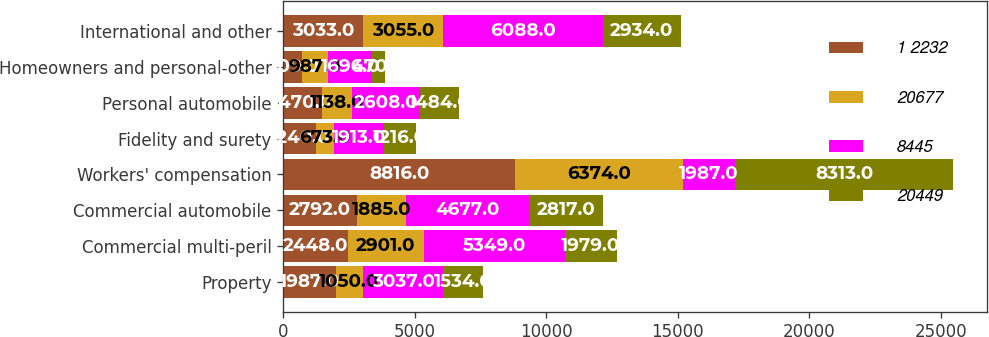Convert chart to OTSL. <chart><loc_0><loc_0><loc_500><loc_500><stacked_bar_chart><ecel><fcel>Property<fcel>Commercial multi-peril<fcel>Commercial automobile<fcel>Workers' compensation<fcel>Fidelity and surety<fcel>Personal automobile<fcel>Homeowners and personal-other<fcel>International and other<nl><fcel>1 2232<fcel>1987<fcel>2448<fcel>2792<fcel>8816<fcel>1240<fcel>1470<fcel>709<fcel>3033<nl><fcel>20677<fcel>1050<fcel>2901<fcel>1885<fcel>6374<fcel>673<fcel>1138<fcel>987<fcel>3055<nl><fcel>8445<fcel>3037<fcel>5349<fcel>4677<fcel>1987<fcel>1913<fcel>2608<fcel>1696<fcel>6088<nl><fcel>20449<fcel>1534<fcel>1979<fcel>2817<fcel>8313<fcel>1216<fcel>1484<fcel>470<fcel>2934<nl></chart> 